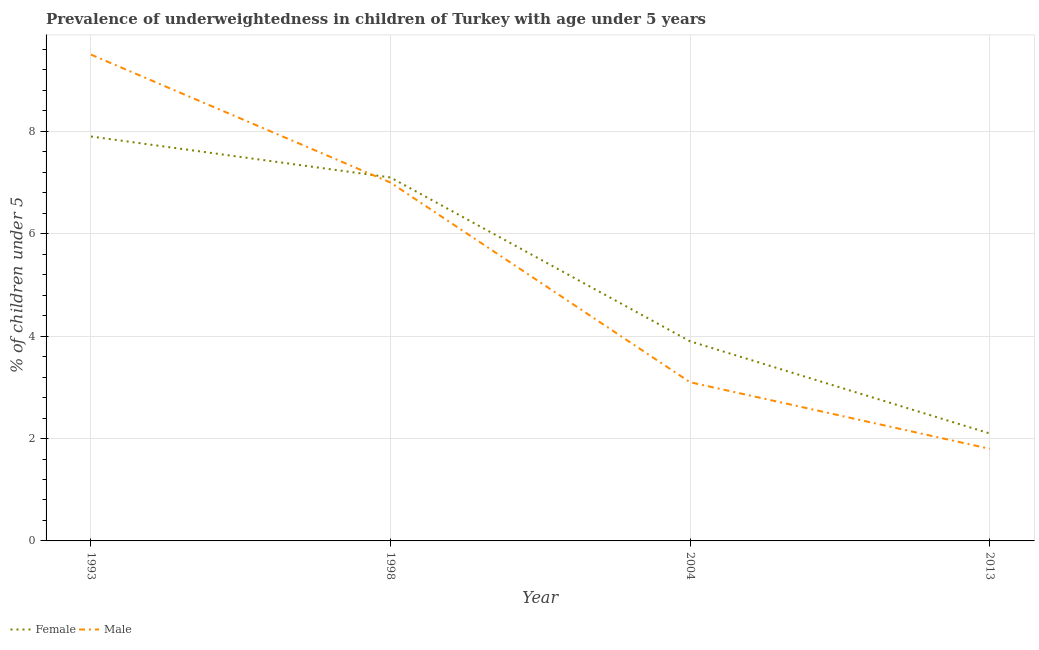How many different coloured lines are there?
Offer a terse response. 2. Does the line corresponding to percentage of underweighted female children intersect with the line corresponding to percentage of underweighted male children?
Your answer should be very brief. Yes. What is the percentage of underweighted male children in 2004?
Provide a short and direct response. 3.1. Across all years, what is the minimum percentage of underweighted female children?
Offer a very short reply. 2.1. In which year was the percentage of underweighted male children maximum?
Your response must be concise. 1993. In which year was the percentage of underweighted male children minimum?
Make the answer very short. 2013. What is the total percentage of underweighted male children in the graph?
Offer a terse response. 21.4. What is the difference between the percentage of underweighted male children in 1993 and that in 1998?
Give a very brief answer. 2.5. What is the difference between the percentage of underweighted female children in 2013 and the percentage of underweighted male children in 1993?
Offer a terse response. -7.4. What is the average percentage of underweighted female children per year?
Your answer should be very brief. 5.25. In the year 2004, what is the difference between the percentage of underweighted male children and percentage of underweighted female children?
Give a very brief answer. -0.8. What is the ratio of the percentage of underweighted female children in 1993 to that in 2004?
Give a very brief answer. 2.03. What is the difference between the highest and the second highest percentage of underweighted male children?
Make the answer very short. 2.5. What is the difference between the highest and the lowest percentage of underweighted male children?
Give a very brief answer. 7.7. In how many years, is the percentage of underweighted male children greater than the average percentage of underweighted male children taken over all years?
Ensure brevity in your answer.  2. Does the percentage of underweighted female children monotonically increase over the years?
Your answer should be compact. No. Is the percentage of underweighted female children strictly greater than the percentage of underweighted male children over the years?
Provide a short and direct response. No. Is the percentage of underweighted male children strictly less than the percentage of underweighted female children over the years?
Keep it short and to the point. No. How many lines are there?
Provide a short and direct response. 2. Does the graph contain grids?
Offer a very short reply. Yes. Where does the legend appear in the graph?
Offer a terse response. Bottom left. How are the legend labels stacked?
Your answer should be compact. Horizontal. What is the title of the graph?
Make the answer very short. Prevalence of underweightedness in children of Turkey with age under 5 years. What is the label or title of the X-axis?
Keep it short and to the point. Year. What is the label or title of the Y-axis?
Provide a short and direct response.  % of children under 5. What is the  % of children under 5 in Female in 1993?
Give a very brief answer. 7.9. What is the  % of children under 5 of Male in 1993?
Make the answer very short. 9.5. What is the  % of children under 5 of Female in 1998?
Give a very brief answer. 7.1. What is the  % of children under 5 in Female in 2004?
Provide a succinct answer. 3.9. What is the  % of children under 5 of Male in 2004?
Give a very brief answer. 3.1. What is the  % of children under 5 in Female in 2013?
Your answer should be compact. 2.1. What is the  % of children under 5 in Male in 2013?
Your answer should be compact. 1.8. Across all years, what is the maximum  % of children under 5 of Female?
Keep it short and to the point. 7.9. Across all years, what is the maximum  % of children under 5 in Male?
Provide a short and direct response. 9.5. Across all years, what is the minimum  % of children under 5 in Female?
Offer a very short reply. 2.1. Across all years, what is the minimum  % of children under 5 of Male?
Provide a succinct answer. 1.8. What is the total  % of children under 5 in Female in the graph?
Keep it short and to the point. 21. What is the total  % of children under 5 in Male in the graph?
Keep it short and to the point. 21.4. What is the difference between the  % of children under 5 in Female in 1993 and that in 1998?
Your answer should be compact. 0.8. What is the difference between the  % of children under 5 in Male in 1993 and that in 1998?
Offer a very short reply. 2.5. What is the difference between the  % of children under 5 in Female in 1993 and that in 2004?
Keep it short and to the point. 4. What is the difference between the  % of children under 5 of Male in 1993 and that in 2004?
Offer a terse response. 6.4. What is the difference between the  % of children under 5 in Female in 1993 and that in 2013?
Provide a short and direct response. 5.8. What is the difference between the  % of children under 5 in Male in 1993 and that in 2013?
Provide a succinct answer. 7.7. What is the difference between the  % of children under 5 of Female in 1998 and that in 2004?
Give a very brief answer. 3.2. What is the difference between the  % of children under 5 of Male in 1998 and that in 2013?
Offer a terse response. 5.2. What is the difference between the  % of children under 5 of Female in 2004 and that in 2013?
Your answer should be very brief. 1.8. What is the difference between the  % of children under 5 in Female in 1998 and the  % of children under 5 in Male in 2004?
Your response must be concise. 4. What is the difference between the  % of children under 5 in Female in 1998 and the  % of children under 5 in Male in 2013?
Your response must be concise. 5.3. What is the difference between the  % of children under 5 of Female in 2004 and the  % of children under 5 of Male in 2013?
Provide a short and direct response. 2.1. What is the average  % of children under 5 of Female per year?
Give a very brief answer. 5.25. What is the average  % of children under 5 of Male per year?
Offer a very short reply. 5.35. In the year 2004, what is the difference between the  % of children under 5 of Female and  % of children under 5 of Male?
Offer a very short reply. 0.8. What is the ratio of the  % of children under 5 in Female in 1993 to that in 1998?
Offer a terse response. 1.11. What is the ratio of the  % of children under 5 of Male in 1993 to that in 1998?
Provide a short and direct response. 1.36. What is the ratio of the  % of children under 5 in Female in 1993 to that in 2004?
Make the answer very short. 2.03. What is the ratio of the  % of children under 5 of Male in 1993 to that in 2004?
Provide a short and direct response. 3.06. What is the ratio of the  % of children under 5 in Female in 1993 to that in 2013?
Offer a very short reply. 3.76. What is the ratio of the  % of children under 5 of Male in 1993 to that in 2013?
Offer a terse response. 5.28. What is the ratio of the  % of children under 5 in Female in 1998 to that in 2004?
Your answer should be compact. 1.82. What is the ratio of the  % of children under 5 of Male in 1998 to that in 2004?
Your answer should be compact. 2.26. What is the ratio of the  % of children under 5 in Female in 1998 to that in 2013?
Provide a succinct answer. 3.38. What is the ratio of the  % of children under 5 in Male in 1998 to that in 2013?
Keep it short and to the point. 3.89. What is the ratio of the  % of children under 5 in Female in 2004 to that in 2013?
Offer a terse response. 1.86. What is the ratio of the  % of children under 5 of Male in 2004 to that in 2013?
Keep it short and to the point. 1.72. What is the difference between the highest and the second highest  % of children under 5 of Female?
Keep it short and to the point. 0.8. What is the difference between the highest and the lowest  % of children under 5 in Female?
Ensure brevity in your answer.  5.8. 